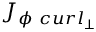<formula> <loc_0><loc_0><loc_500><loc_500>{ J } _ { \phi \ c u r l _ { \perp } }</formula> 